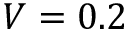Convert formula to latex. <formula><loc_0><loc_0><loc_500><loc_500>V = 0 . 2</formula> 